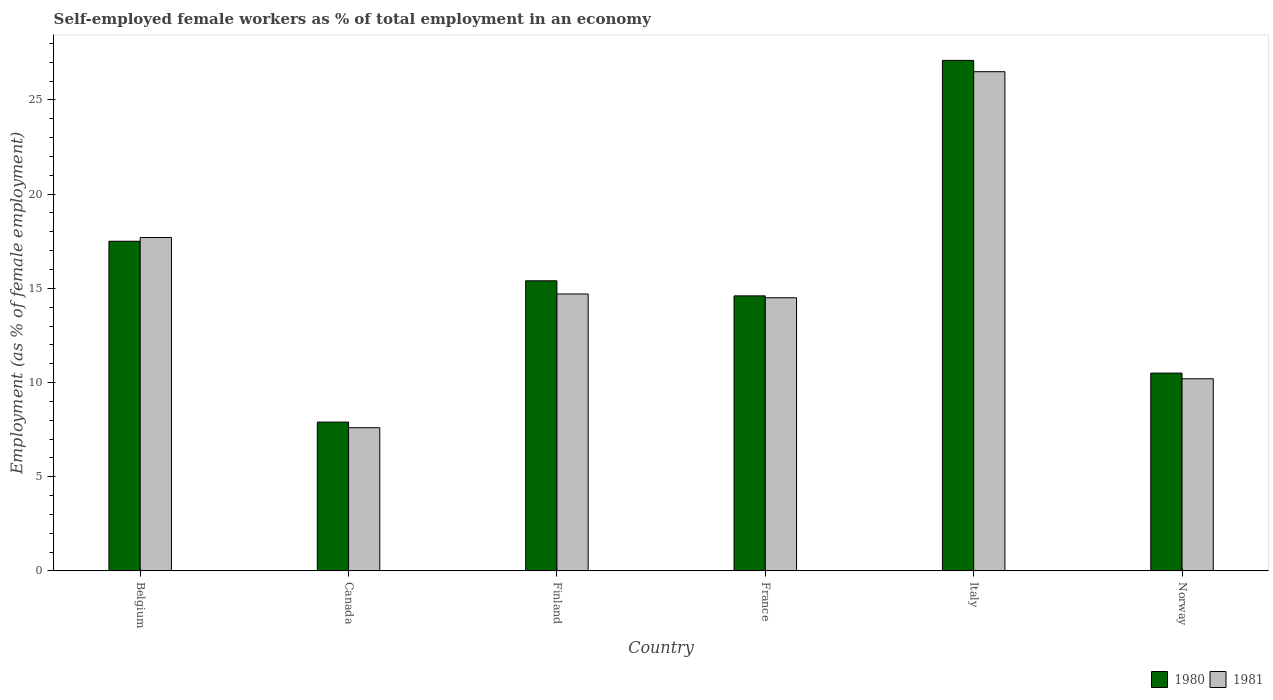How many different coloured bars are there?
Your answer should be compact. 2. Are the number of bars per tick equal to the number of legend labels?
Give a very brief answer. Yes. How many bars are there on the 2nd tick from the left?
Ensure brevity in your answer.  2. What is the label of the 4th group of bars from the left?
Offer a terse response. France. What is the percentage of self-employed female workers in 1981 in Finland?
Your response must be concise. 14.7. Across all countries, what is the minimum percentage of self-employed female workers in 1980?
Give a very brief answer. 7.9. In which country was the percentage of self-employed female workers in 1980 maximum?
Your answer should be compact. Italy. What is the total percentage of self-employed female workers in 1981 in the graph?
Your answer should be compact. 91.2. What is the difference between the percentage of self-employed female workers in 1980 in Finland and that in Italy?
Offer a very short reply. -11.7. What is the difference between the percentage of self-employed female workers in 1980 in Italy and the percentage of self-employed female workers in 1981 in Canada?
Offer a terse response. 19.5. What is the average percentage of self-employed female workers in 1980 per country?
Your answer should be compact. 15.5. What is the difference between the percentage of self-employed female workers of/in 1981 and percentage of self-employed female workers of/in 1980 in France?
Offer a terse response. -0.1. In how many countries, is the percentage of self-employed female workers in 1980 greater than 15 %?
Your response must be concise. 3. What is the ratio of the percentage of self-employed female workers in 1981 in Belgium to that in Finland?
Offer a very short reply. 1.2. What is the difference between the highest and the second highest percentage of self-employed female workers in 1981?
Offer a very short reply. -8.8. What is the difference between the highest and the lowest percentage of self-employed female workers in 1981?
Provide a succinct answer. 18.9. In how many countries, is the percentage of self-employed female workers in 1980 greater than the average percentage of self-employed female workers in 1980 taken over all countries?
Ensure brevity in your answer.  2. What does the 1st bar from the left in Finland represents?
Offer a terse response. 1980. What does the 2nd bar from the right in Belgium represents?
Your answer should be compact. 1980. How many countries are there in the graph?
Your answer should be compact. 6. Are the values on the major ticks of Y-axis written in scientific E-notation?
Provide a short and direct response. No. Does the graph contain grids?
Your answer should be compact. No. Where does the legend appear in the graph?
Your answer should be very brief. Bottom right. What is the title of the graph?
Provide a succinct answer. Self-employed female workers as % of total employment in an economy. What is the label or title of the Y-axis?
Your response must be concise. Employment (as % of female employment). What is the Employment (as % of female employment) of 1980 in Belgium?
Make the answer very short. 17.5. What is the Employment (as % of female employment) in 1981 in Belgium?
Your response must be concise. 17.7. What is the Employment (as % of female employment) of 1980 in Canada?
Give a very brief answer. 7.9. What is the Employment (as % of female employment) in 1981 in Canada?
Keep it short and to the point. 7.6. What is the Employment (as % of female employment) of 1980 in Finland?
Your answer should be very brief. 15.4. What is the Employment (as % of female employment) in 1981 in Finland?
Offer a terse response. 14.7. What is the Employment (as % of female employment) of 1980 in France?
Provide a succinct answer. 14.6. What is the Employment (as % of female employment) in 1981 in France?
Make the answer very short. 14.5. What is the Employment (as % of female employment) of 1980 in Italy?
Your response must be concise. 27.1. What is the Employment (as % of female employment) in 1981 in Norway?
Keep it short and to the point. 10.2. Across all countries, what is the maximum Employment (as % of female employment) in 1980?
Give a very brief answer. 27.1. Across all countries, what is the minimum Employment (as % of female employment) of 1980?
Keep it short and to the point. 7.9. Across all countries, what is the minimum Employment (as % of female employment) of 1981?
Your answer should be very brief. 7.6. What is the total Employment (as % of female employment) in 1980 in the graph?
Your answer should be compact. 93. What is the total Employment (as % of female employment) of 1981 in the graph?
Give a very brief answer. 91.2. What is the difference between the Employment (as % of female employment) of 1980 in Belgium and that in Canada?
Your response must be concise. 9.6. What is the difference between the Employment (as % of female employment) in 1980 in Belgium and that in France?
Keep it short and to the point. 2.9. What is the difference between the Employment (as % of female employment) in 1981 in Belgium and that in France?
Offer a very short reply. 3.2. What is the difference between the Employment (as % of female employment) in 1981 in Belgium and that in Italy?
Offer a terse response. -8.8. What is the difference between the Employment (as % of female employment) in 1981 in Canada and that in France?
Your answer should be compact. -6.9. What is the difference between the Employment (as % of female employment) of 1980 in Canada and that in Italy?
Your response must be concise. -19.2. What is the difference between the Employment (as % of female employment) of 1981 in Canada and that in Italy?
Provide a succinct answer. -18.9. What is the difference between the Employment (as % of female employment) in 1980 in Finland and that in Norway?
Offer a very short reply. 4.9. What is the difference between the Employment (as % of female employment) in 1981 in France and that in Norway?
Give a very brief answer. 4.3. What is the difference between the Employment (as % of female employment) in 1980 in Italy and that in Norway?
Your response must be concise. 16.6. What is the difference between the Employment (as % of female employment) in 1981 in Italy and that in Norway?
Offer a terse response. 16.3. What is the difference between the Employment (as % of female employment) of 1980 in Belgium and the Employment (as % of female employment) of 1981 in Canada?
Your response must be concise. 9.9. What is the difference between the Employment (as % of female employment) in 1980 in Belgium and the Employment (as % of female employment) in 1981 in Finland?
Give a very brief answer. 2.8. What is the difference between the Employment (as % of female employment) in 1980 in Belgium and the Employment (as % of female employment) in 1981 in France?
Keep it short and to the point. 3. What is the difference between the Employment (as % of female employment) of 1980 in Belgium and the Employment (as % of female employment) of 1981 in Norway?
Ensure brevity in your answer.  7.3. What is the difference between the Employment (as % of female employment) of 1980 in Canada and the Employment (as % of female employment) of 1981 in Finland?
Your answer should be very brief. -6.8. What is the difference between the Employment (as % of female employment) of 1980 in Canada and the Employment (as % of female employment) of 1981 in France?
Ensure brevity in your answer.  -6.6. What is the difference between the Employment (as % of female employment) of 1980 in Canada and the Employment (as % of female employment) of 1981 in Italy?
Keep it short and to the point. -18.6. What is the difference between the Employment (as % of female employment) of 1980 in Canada and the Employment (as % of female employment) of 1981 in Norway?
Make the answer very short. -2.3. What is the difference between the Employment (as % of female employment) in 1980 in Finland and the Employment (as % of female employment) in 1981 in France?
Offer a very short reply. 0.9. What is the difference between the Employment (as % of female employment) in 1980 in Finland and the Employment (as % of female employment) in 1981 in Norway?
Offer a very short reply. 5.2. What is the difference between the Employment (as % of female employment) of 1980 in France and the Employment (as % of female employment) of 1981 in Norway?
Make the answer very short. 4.4. What is the difference between the Employment (as % of female employment) in 1980 in Italy and the Employment (as % of female employment) in 1981 in Norway?
Give a very brief answer. 16.9. What is the average Employment (as % of female employment) in 1980 per country?
Ensure brevity in your answer.  15.5. What is the difference between the Employment (as % of female employment) of 1980 and Employment (as % of female employment) of 1981 in Belgium?
Keep it short and to the point. -0.2. What is the difference between the Employment (as % of female employment) in 1980 and Employment (as % of female employment) in 1981 in Finland?
Offer a very short reply. 0.7. What is the difference between the Employment (as % of female employment) in 1980 and Employment (as % of female employment) in 1981 in France?
Keep it short and to the point. 0.1. What is the difference between the Employment (as % of female employment) in 1980 and Employment (as % of female employment) in 1981 in Italy?
Offer a very short reply. 0.6. What is the ratio of the Employment (as % of female employment) of 1980 in Belgium to that in Canada?
Provide a succinct answer. 2.22. What is the ratio of the Employment (as % of female employment) in 1981 in Belgium to that in Canada?
Provide a succinct answer. 2.33. What is the ratio of the Employment (as % of female employment) of 1980 in Belgium to that in Finland?
Provide a short and direct response. 1.14. What is the ratio of the Employment (as % of female employment) of 1981 in Belgium to that in Finland?
Provide a succinct answer. 1.2. What is the ratio of the Employment (as % of female employment) of 1980 in Belgium to that in France?
Ensure brevity in your answer.  1.2. What is the ratio of the Employment (as % of female employment) of 1981 in Belgium to that in France?
Your answer should be compact. 1.22. What is the ratio of the Employment (as % of female employment) in 1980 in Belgium to that in Italy?
Ensure brevity in your answer.  0.65. What is the ratio of the Employment (as % of female employment) in 1981 in Belgium to that in Italy?
Make the answer very short. 0.67. What is the ratio of the Employment (as % of female employment) in 1980 in Belgium to that in Norway?
Make the answer very short. 1.67. What is the ratio of the Employment (as % of female employment) in 1981 in Belgium to that in Norway?
Your answer should be very brief. 1.74. What is the ratio of the Employment (as % of female employment) of 1980 in Canada to that in Finland?
Your response must be concise. 0.51. What is the ratio of the Employment (as % of female employment) of 1981 in Canada to that in Finland?
Offer a very short reply. 0.52. What is the ratio of the Employment (as % of female employment) in 1980 in Canada to that in France?
Your response must be concise. 0.54. What is the ratio of the Employment (as % of female employment) of 1981 in Canada to that in France?
Your answer should be very brief. 0.52. What is the ratio of the Employment (as % of female employment) in 1980 in Canada to that in Italy?
Make the answer very short. 0.29. What is the ratio of the Employment (as % of female employment) of 1981 in Canada to that in Italy?
Offer a very short reply. 0.29. What is the ratio of the Employment (as % of female employment) of 1980 in Canada to that in Norway?
Ensure brevity in your answer.  0.75. What is the ratio of the Employment (as % of female employment) in 1981 in Canada to that in Norway?
Ensure brevity in your answer.  0.75. What is the ratio of the Employment (as % of female employment) in 1980 in Finland to that in France?
Provide a short and direct response. 1.05. What is the ratio of the Employment (as % of female employment) in 1981 in Finland to that in France?
Offer a terse response. 1.01. What is the ratio of the Employment (as % of female employment) of 1980 in Finland to that in Italy?
Provide a succinct answer. 0.57. What is the ratio of the Employment (as % of female employment) in 1981 in Finland to that in Italy?
Your response must be concise. 0.55. What is the ratio of the Employment (as % of female employment) of 1980 in Finland to that in Norway?
Provide a succinct answer. 1.47. What is the ratio of the Employment (as % of female employment) of 1981 in Finland to that in Norway?
Your answer should be very brief. 1.44. What is the ratio of the Employment (as % of female employment) in 1980 in France to that in Italy?
Offer a terse response. 0.54. What is the ratio of the Employment (as % of female employment) in 1981 in France to that in Italy?
Provide a succinct answer. 0.55. What is the ratio of the Employment (as % of female employment) of 1980 in France to that in Norway?
Make the answer very short. 1.39. What is the ratio of the Employment (as % of female employment) of 1981 in France to that in Norway?
Provide a succinct answer. 1.42. What is the ratio of the Employment (as % of female employment) of 1980 in Italy to that in Norway?
Offer a very short reply. 2.58. What is the ratio of the Employment (as % of female employment) in 1981 in Italy to that in Norway?
Your response must be concise. 2.6. What is the difference between the highest and the lowest Employment (as % of female employment) of 1980?
Your response must be concise. 19.2. 